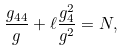<formula> <loc_0><loc_0><loc_500><loc_500>\frac { g _ { 4 4 } } { g } + \ell \frac { g ^ { 2 } _ { 4 } } { g ^ { 2 } } = N ,</formula> 